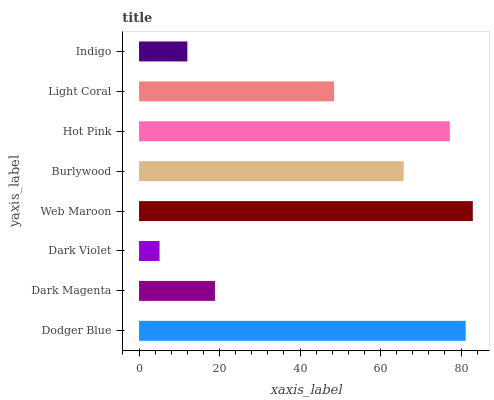Is Dark Violet the minimum?
Answer yes or no. Yes. Is Web Maroon the maximum?
Answer yes or no. Yes. Is Dark Magenta the minimum?
Answer yes or no. No. Is Dark Magenta the maximum?
Answer yes or no. No. Is Dodger Blue greater than Dark Magenta?
Answer yes or no. Yes. Is Dark Magenta less than Dodger Blue?
Answer yes or no. Yes. Is Dark Magenta greater than Dodger Blue?
Answer yes or no. No. Is Dodger Blue less than Dark Magenta?
Answer yes or no. No. Is Burlywood the high median?
Answer yes or no. Yes. Is Light Coral the low median?
Answer yes or no. Yes. Is Hot Pink the high median?
Answer yes or no. No. Is Hot Pink the low median?
Answer yes or no. No. 